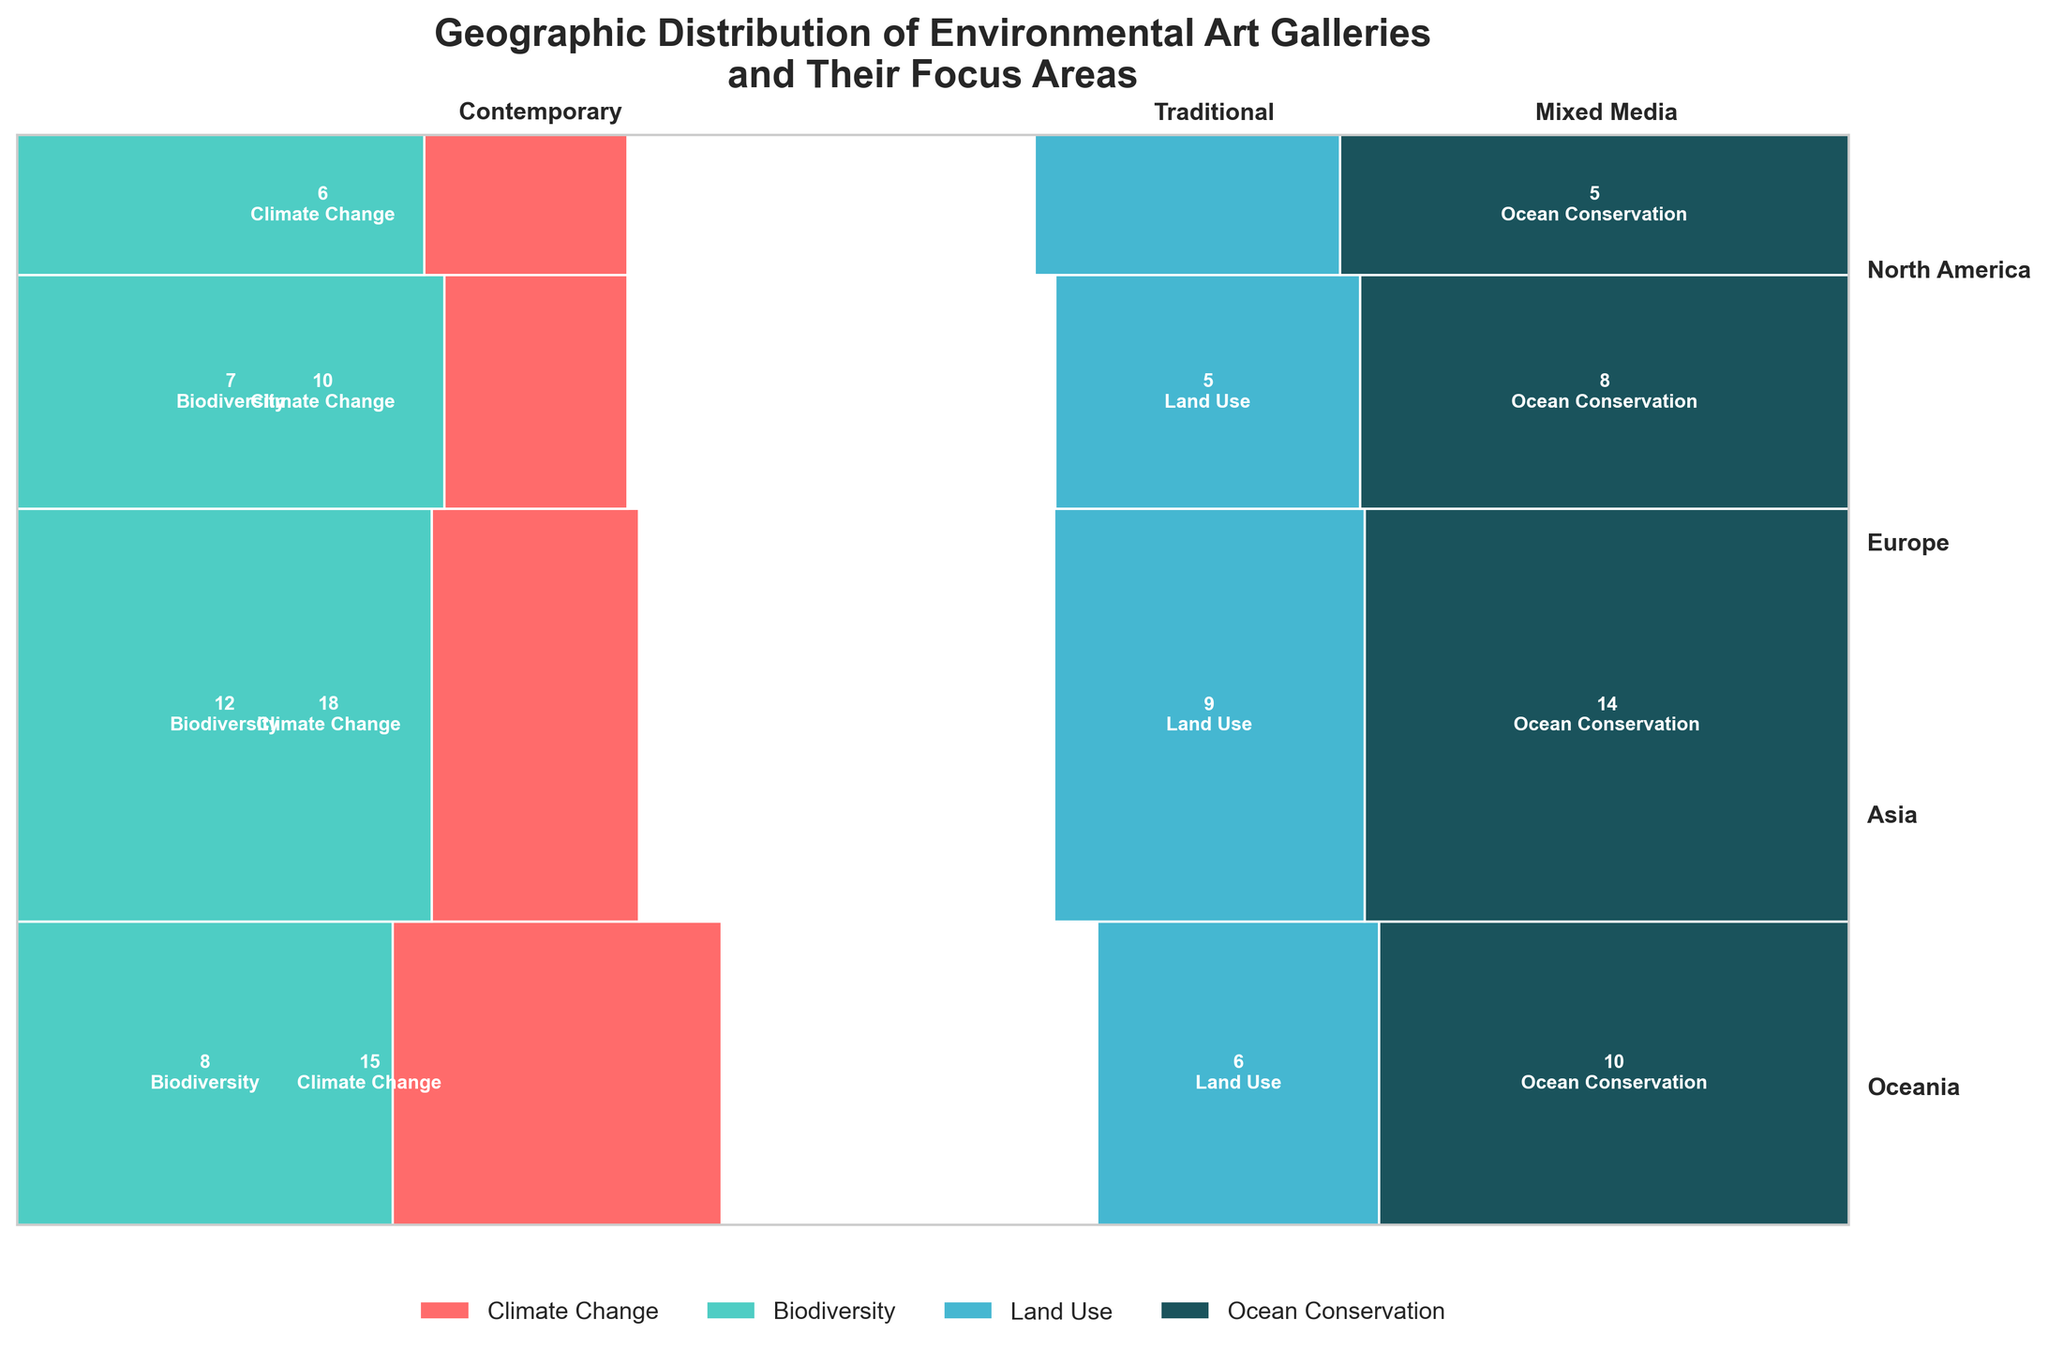Which region has the highest number of galleries focused on Climate Change? Europe has the highest number of galleries focused on Climate Change. You can determine this by looking at the highest rectangle with the color representing "Climate Change" in each region. Europe has 18 galleries for this focus area, which is more than any other region.
Answer: Europe Which gallery type is most common in North America? To find the most common gallery type in North America, look at the width of the bars corresponding to each gallery type in the North America section. The widest bar indicates the most common type. For North America, Contemporary galleries are the most common with multiple focus areas combined.
Answer: Contemporary How many galleries in total focus on Biodiversity? The total number of galleries focusing on Biodiversity can be found by summing up the respective counts in all the regions. North America has 8, Europe has 12, Asia has 7, and Oceania has 4. Summing these gives 8 + 12 +7 + 4 = 31.
Answer: 31 Which region has the least total number of galleries? To find the region with the least total number of galleries, compare the total height of the bars for each region. Oceania has the least total number of galleries as it has the shortest combined bar height.
Answer: Oceania In Asia, which focus area has the fewest galleries? To find the focus area with the fewest galleries in Asia, look at the smallest rectangle within Asia's section. The smallest bar corresponds to "Land Use" with a count of 5 galleries.
Answer: Land Use Are there more galleries focusing on Ocean Conservation in North America or Asia? Compare the heights of the rectangles representing Ocean Conservation in North America and Asia. North America's bar is higher with a count of 10 as compared to Asia's bar height representing 8.
Answer: North America What is the total number of Traditional galleries across all regions? Sum the number of Traditional galleries in each region. North America has 6, Europe has 9, Asia has 5, and Oceania has 3. Summing these gives 6 + 9 + 5 + 3 = 23.
Answer: 23 Which gallery type in Europe has the most galleries and what is its focus area? Identify the gallery type with the largest width among the Europe section. The largest width corresponds to "Contemporary" galleries. Next, find the focus area within this type that has the largest count. For Contemporary type, Climate Change with 18 is the highest.
Answer: Contemporary, Climate Change What percentage of Mixed Media galleries focus on Ocean Conservation in Europe? To calculate the percentage, find the number of Mixed Media galleries in Europe focusing on Ocean Conservation and the total Mixed Media galleries in Europe. Europe has 14 galleries in Mixed Media focusing on Ocean Conservation. Summing Mixed Media (14 mixed-media + 0 other) gives 14. Hence, the percentage is (14/14) * 100% = 100%.
Answer: 100% Which region has the highest diversity of focus areas within Contemporary galleries? To find the region with the highest diversity of focus areas within Contemporary galleries, check the number of different colored rectangles under Contemporary section for each region. Europe has distinct rectangles for both "Climate Change" and "Biodiversity", indicating higher diversity.
Answer: Europe 